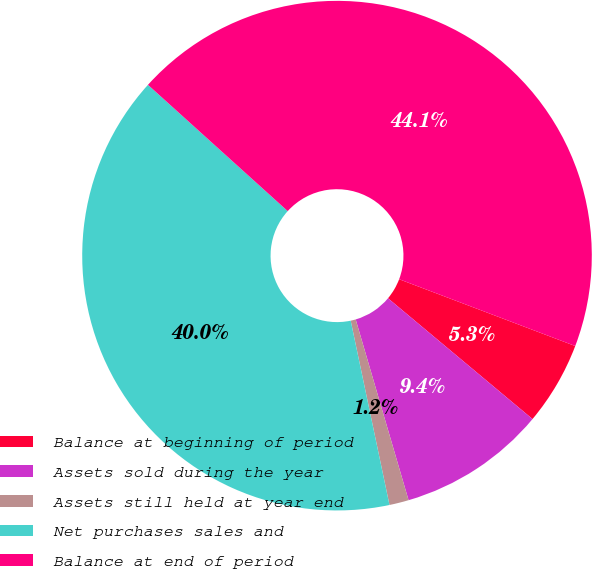<chart> <loc_0><loc_0><loc_500><loc_500><pie_chart><fcel>Balance at beginning of period<fcel>Assets sold during the year<fcel>Assets still held at year end<fcel>Net purchases sales and<fcel>Balance at end of period<nl><fcel>5.31%<fcel>9.39%<fcel>1.23%<fcel>40.0%<fcel>44.08%<nl></chart> 